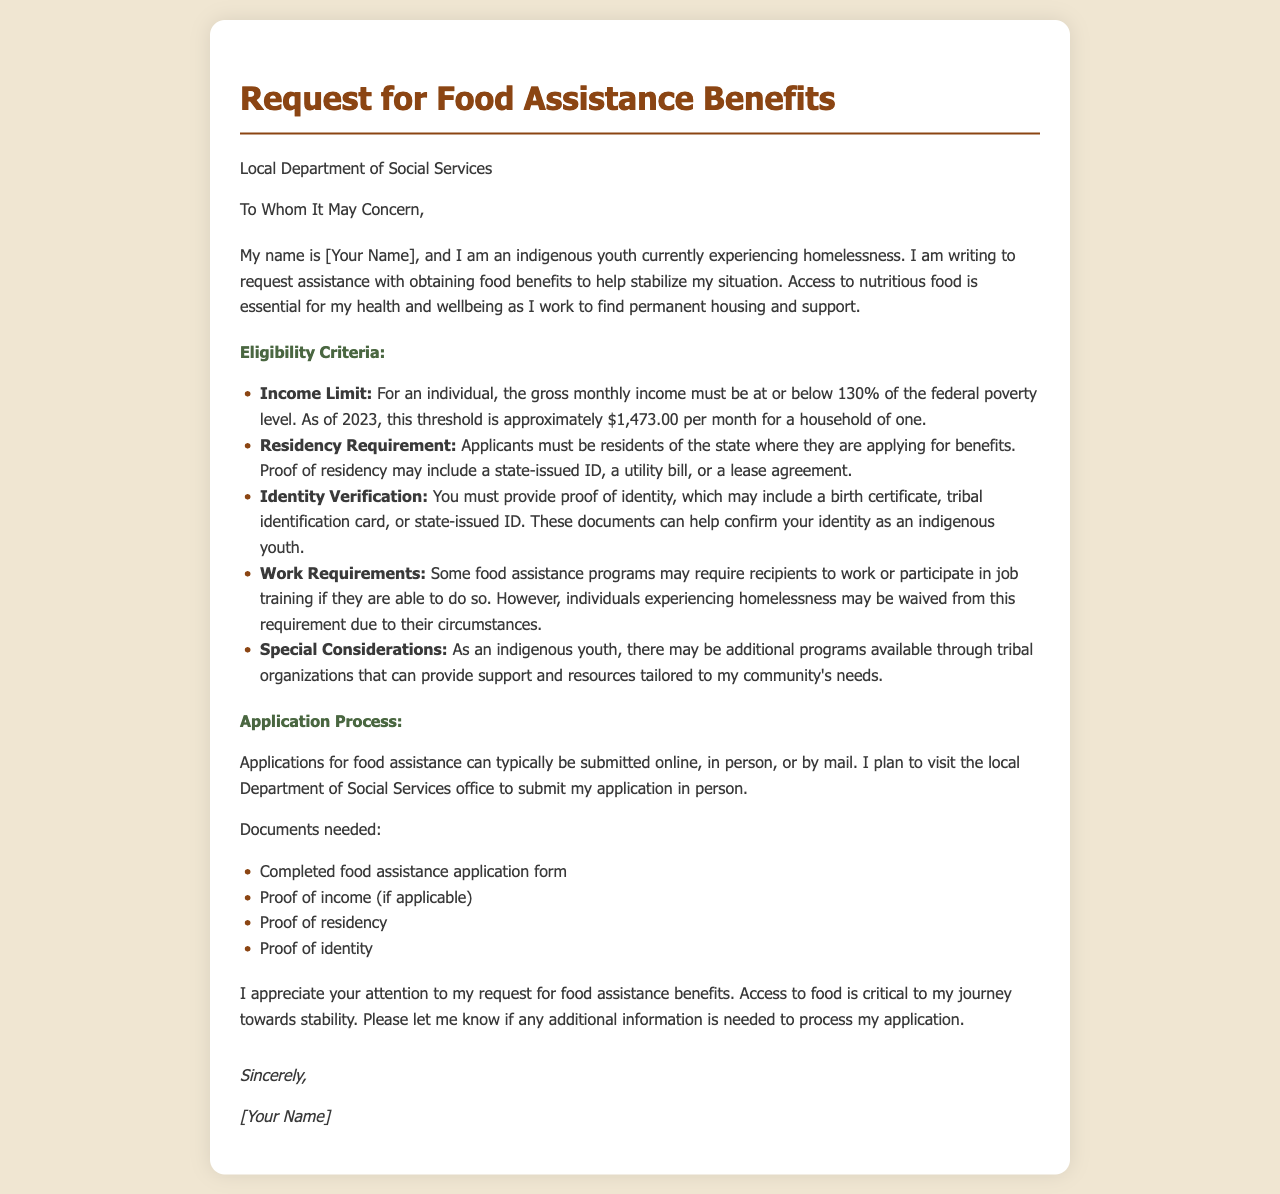What is the purpose of the letter? The letter is a request for food assistance benefits to help stabilize the author's situation.
Answer: Request for food assistance benefits Who is the letter addressed to? The letter is addressed to the local Department of Social Services.
Answer: Local Department of Social Services What is the income limit for an individual seeking benefits? The income limit for an individual is set at 130% of the federal poverty level, which is approximately $1,473.00.
Answer: $1,473.00 What documents are needed to apply for food assistance? The documents needed include a completed application form, proof of income, proof of residency, and proof of identity.
Answer: Completed application form, proof of income, proof of residency, proof of identity What term refers to the requirement that some assistance programs may expect recipients to do? This term is "Work Requirements."
Answer: Work Requirements What special consideration is mentioned for indigenous youth? There may be additional programs available through tribal organizations that provide tailored support.
Answer: Additional programs through tribal organizations What is the main theme of the eligibility criteria section? It describes the essential qualifications needed to receive food assistance benefits.
Answer: Qualifications for food assistance benefits How can applications for food assistance be submitted? Applications can be submitted online, in person, or by mail.
Answer: Online, in person, or by mail What is the opening line of the letter? The opening line introduces the author and establishes their situation regarding homelessness.
Answer: My name is [Your Name], and I am an indigenous youth currently experiencing homelessness What kind of identification is accepted for identity verification? Accepted identification includes a birth certificate, tribal identification card, or state-issued ID.
Answer: Birth certificate, tribal identification card, or state-issued ID 